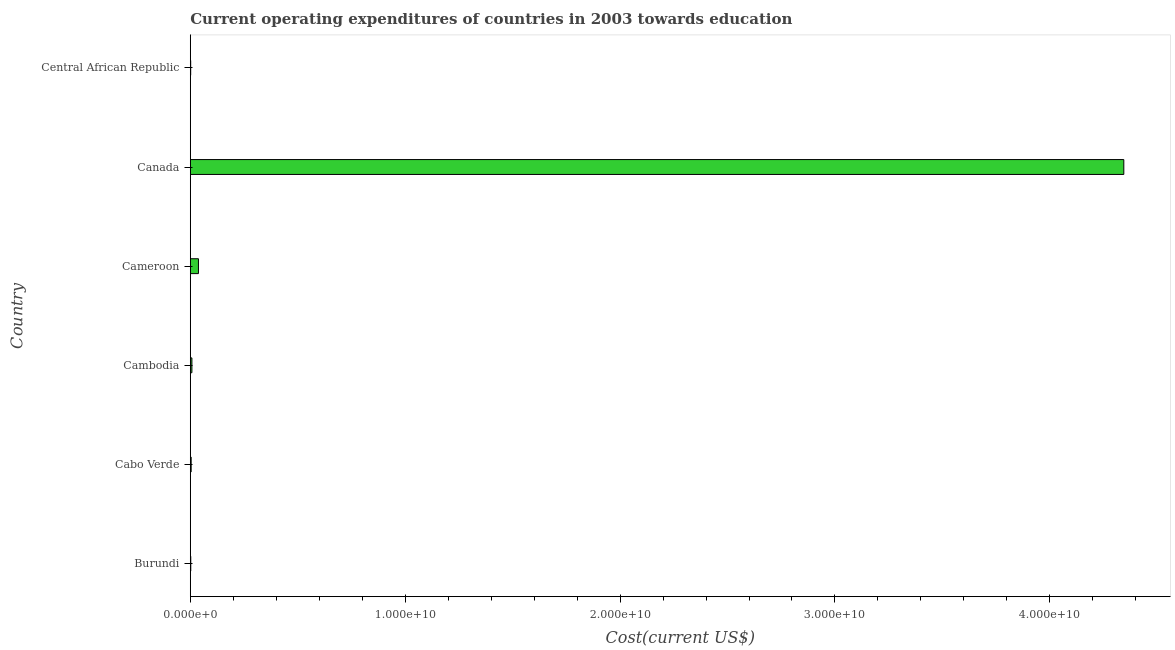Does the graph contain any zero values?
Offer a very short reply. No. What is the title of the graph?
Ensure brevity in your answer.  Current operating expenditures of countries in 2003 towards education. What is the label or title of the X-axis?
Make the answer very short. Cost(current US$). What is the education expenditure in Burundi?
Provide a short and direct response. 2.16e+07. Across all countries, what is the maximum education expenditure?
Your answer should be compact. 4.34e+1. Across all countries, what is the minimum education expenditure?
Your answer should be very brief. 1.82e+07. In which country was the education expenditure minimum?
Your answer should be very brief. Central African Republic. What is the sum of the education expenditure?
Make the answer very short. 4.40e+1. What is the difference between the education expenditure in Burundi and Cabo Verde?
Offer a very short reply. -1.88e+07. What is the average education expenditure per country?
Your answer should be compact. 7.33e+09. What is the median education expenditure?
Provide a succinct answer. 5.75e+07. In how many countries, is the education expenditure greater than 32000000000 US$?
Provide a succinct answer. 1. What is the ratio of the education expenditure in Burundi to that in Canada?
Your answer should be compact. 0. What is the difference between the highest and the second highest education expenditure?
Make the answer very short. 4.31e+1. Is the sum of the education expenditure in Burundi and Cambodia greater than the maximum education expenditure across all countries?
Offer a very short reply. No. What is the difference between the highest and the lowest education expenditure?
Offer a very short reply. 4.34e+1. How many bars are there?
Give a very brief answer. 6. Are all the bars in the graph horizontal?
Keep it short and to the point. Yes. How many countries are there in the graph?
Give a very brief answer. 6. What is the difference between two consecutive major ticks on the X-axis?
Provide a succinct answer. 1.00e+1. What is the Cost(current US$) in Burundi?
Your answer should be compact. 2.16e+07. What is the Cost(current US$) of Cabo Verde?
Your answer should be very brief. 4.04e+07. What is the Cost(current US$) in Cambodia?
Give a very brief answer. 7.47e+07. What is the Cost(current US$) in Cameroon?
Your answer should be compact. 3.80e+08. What is the Cost(current US$) of Canada?
Keep it short and to the point. 4.34e+1. What is the Cost(current US$) in Central African Republic?
Provide a succinct answer. 1.82e+07. What is the difference between the Cost(current US$) in Burundi and Cabo Verde?
Provide a succinct answer. -1.88e+07. What is the difference between the Cost(current US$) in Burundi and Cambodia?
Give a very brief answer. -5.31e+07. What is the difference between the Cost(current US$) in Burundi and Cameroon?
Your answer should be very brief. -3.58e+08. What is the difference between the Cost(current US$) in Burundi and Canada?
Give a very brief answer. -4.34e+1. What is the difference between the Cost(current US$) in Burundi and Central African Republic?
Provide a short and direct response. 3.41e+06. What is the difference between the Cost(current US$) in Cabo Verde and Cambodia?
Offer a very short reply. -3.43e+07. What is the difference between the Cost(current US$) in Cabo Verde and Cameroon?
Give a very brief answer. -3.39e+08. What is the difference between the Cost(current US$) in Cabo Verde and Canada?
Offer a terse response. -4.34e+1. What is the difference between the Cost(current US$) in Cabo Verde and Central African Republic?
Keep it short and to the point. 2.22e+07. What is the difference between the Cost(current US$) in Cambodia and Cameroon?
Give a very brief answer. -3.05e+08. What is the difference between the Cost(current US$) in Cambodia and Canada?
Make the answer very short. -4.34e+1. What is the difference between the Cost(current US$) in Cambodia and Central African Republic?
Your answer should be very brief. 5.65e+07. What is the difference between the Cost(current US$) in Cameroon and Canada?
Provide a succinct answer. -4.31e+1. What is the difference between the Cost(current US$) in Cameroon and Central African Republic?
Your answer should be very brief. 3.62e+08. What is the difference between the Cost(current US$) in Canada and Central African Republic?
Offer a terse response. 4.34e+1. What is the ratio of the Cost(current US$) in Burundi to that in Cabo Verde?
Offer a terse response. 0.54. What is the ratio of the Cost(current US$) in Burundi to that in Cambodia?
Provide a short and direct response. 0.29. What is the ratio of the Cost(current US$) in Burundi to that in Cameroon?
Offer a very short reply. 0.06. What is the ratio of the Cost(current US$) in Burundi to that in Canada?
Ensure brevity in your answer.  0. What is the ratio of the Cost(current US$) in Burundi to that in Central African Republic?
Provide a succinct answer. 1.19. What is the ratio of the Cost(current US$) in Cabo Verde to that in Cambodia?
Provide a short and direct response. 0.54. What is the ratio of the Cost(current US$) in Cabo Verde to that in Cameroon?
Provide a succinct answer. 0.11. What is the ratio of the Cost(current US$) in Cabo Verde to that in Central African Republic?
Your answer should be compact. 2.22. What is the ratio of the Cost(current US$) in Cambodia to that in Cameroon?
Give a very brief answer. 0.2. What is the ratio of the Cost(current US$) in Cambodia to that in Canada?
Your answer should be compact. 0. What is the ratio of the Cost(current US$) in Cambodia to that in Central African Republic?
Ensure brevity in your answer.  4.11. What is the ratio of the Cost(current US$) in Cameroon to that in Canada?
Keep it short and to the point. 0.01. What is the ratio of the Cost(current US$) in Cameroon to that in Central African Republic?
Provide a short and direct response. 20.88. What is the ratio of the Cost(current US$) in Canada to that in Central African Republic?
Ensure brevity in your answer.  2388.09. 